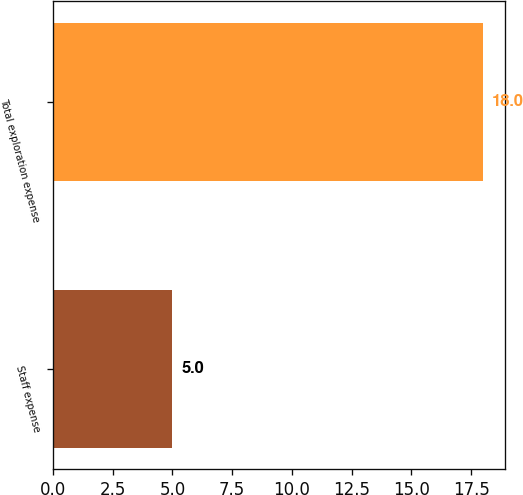Convert chart. <chart><loc_0><loc_0><loc_500><loc_500><bar_chart><fcel>Staff expense<fcel>Total exploration expense<nl><fcel>5<fcel>18<nl></chart> 